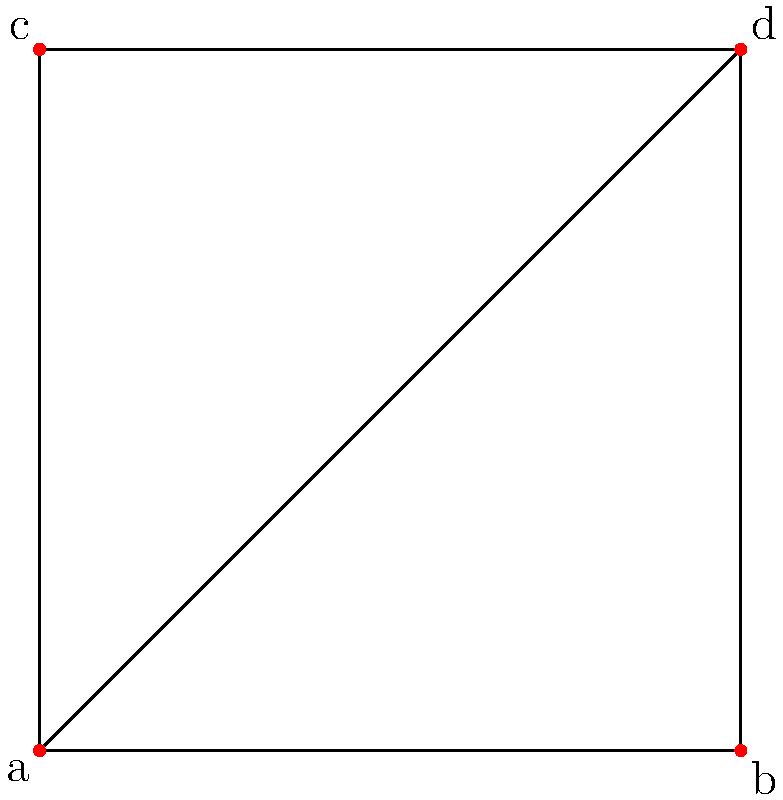Consider the topological space represented by the graph shown above. What is the fundamental group of this space? To find the fundamental group of this topological space, we'll follow these steps:

1) First, observe that the graph is connected and has no self-loops.

2) Count the number of vertices (V) and edges (E):
   V = 4 (labeled a, b, c, d)
   E = 5 (4 outer edges + 1 diagonal)

3) Calculate the first Betti number (β₁), which represents the number of independent cycles:
   β₁ = E - V + 1 = 5 - 4 + 1 = 2

4) The fundamental group of a graph is isomorphic to the free group on β₁ generators.

5) Therefore, the fundamental group is isomorphic to the free group on 2 generators.

In topological notation, this is written as $\pi_1(X) \cong F_2$, where $X$ is our topological space and $F_2$ is the free group on 2 generators.

This result aligns with the intuition that there are two independent loops in the graph: the outer square and either of the two triangles formed by the diagonal.
Answer: $F_2$ 